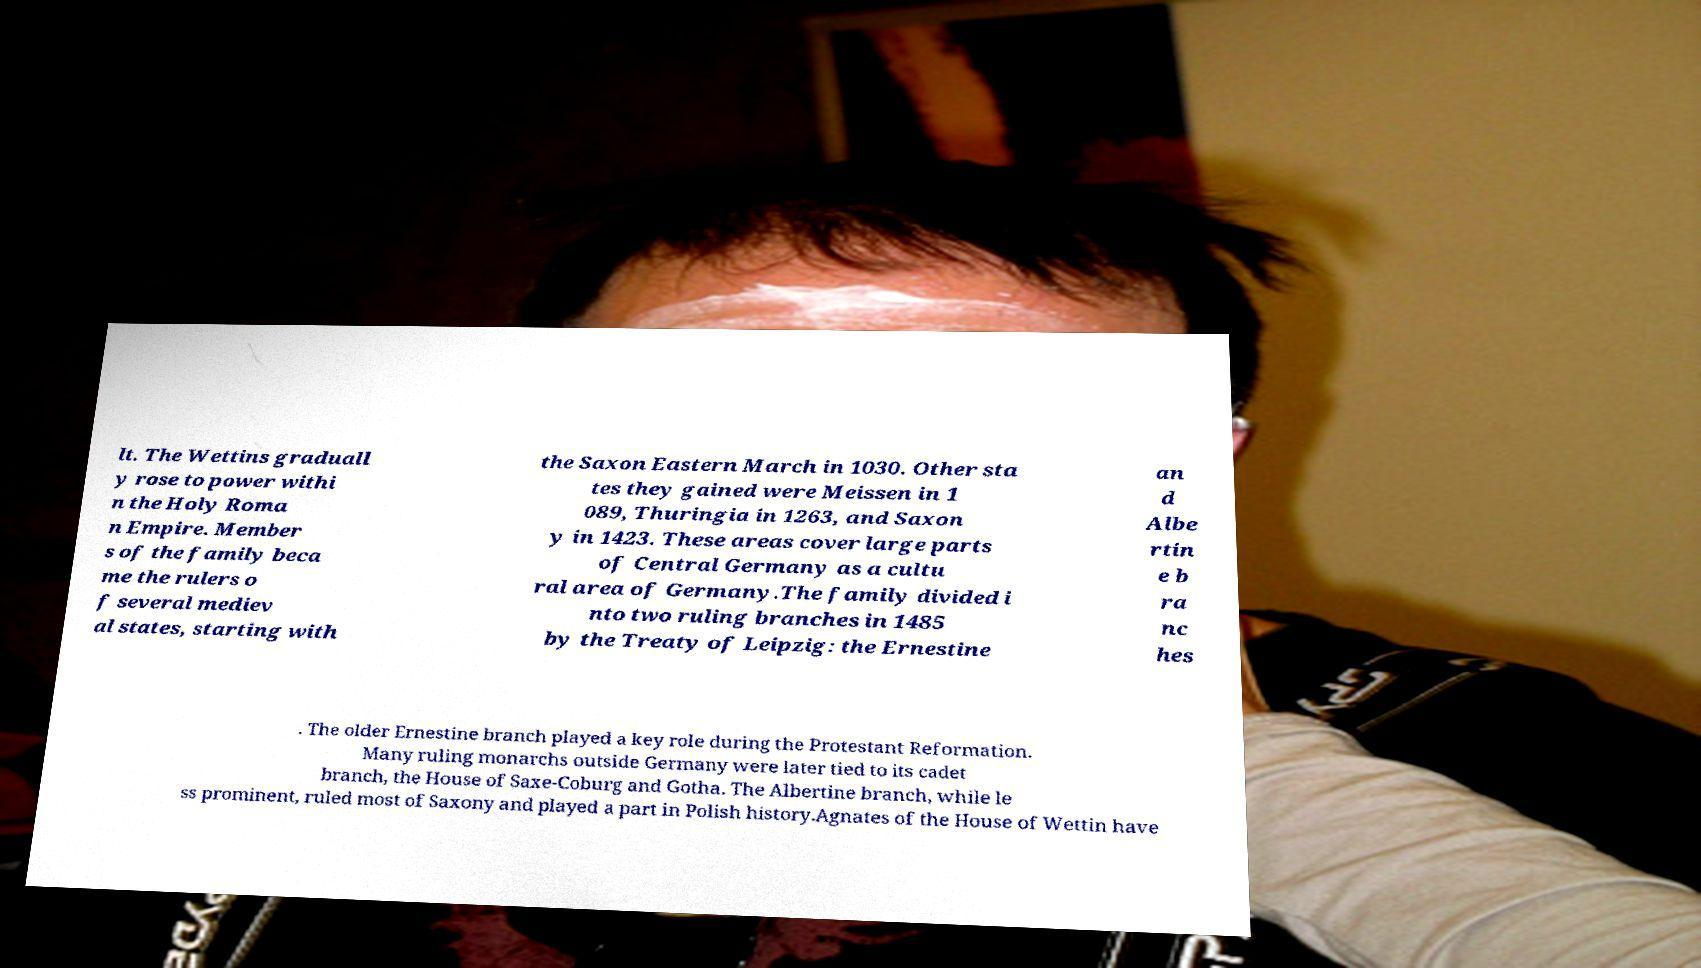Could you assist in decoding the text presented in this image and type it out clearly? lt. The Wettins graduall y rose to power withi n the Holy Roma n Empire. Member s of the family beca me the rulers o f several mediev al states, starting with the Saxon Eastern March in 1030. Other sta tes they gained were Meissen in 1 089, Thuringia in 1263, and Saxon y in 1423. These areas cover large parts of Central Germany as a cultu ral area of Germany.The family divided i nto two ruling branches in 1485 by the Treaty of Leipzig: the Ernestine an d Albe rtin e b ra nc hes . The older Ernestine branch played a key role during the Protestant Reformation. Many ruling monarchs outside Germany were later tied to its cadet branch, the House of Saxe-Coburg and Gotha. The Albertine branch, while le ss prominent, ruled most of Saxony and played a part in Polish history.Agnates of the House of Wettin have 